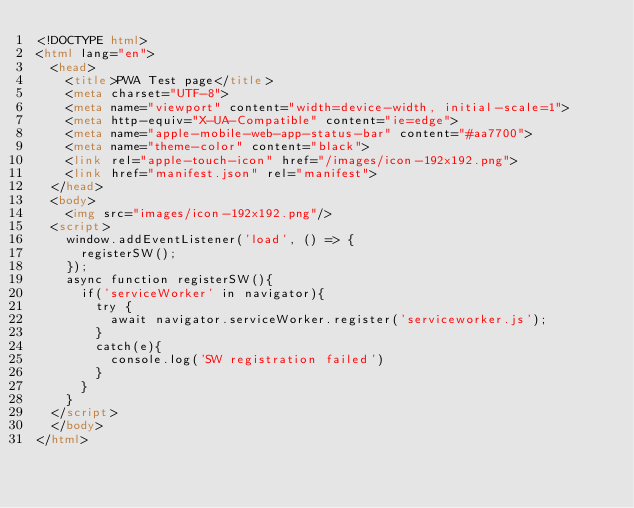<code> <loc_0><loc_0><loc_500><loc_500><_HTML_><!DOCTYPE html>
<html lang="en">
  <head>
    <title>PWA Test page</title>
    <meta charset="UTF-8">
    <meta name="viewport" content="width=device-width, initial-scale=1">
    <meta http-equiv="X-UA-Compatible" content="ie=edge">
    <meta name="apple-mobile-web-app-status-bar" content="#aa7700">
    <meta name="theme-color" content="black">
    <link rel="apple-touch-icon" href="/images/icon-192x192.png">
    <link href="manifest.json" rel="manifest">
  </head>
  <body>
    <img src="images/icon-192x192.png"/>
  <script>
    window.addEventListener('load', () => {
      registerSW();
    }); 
    async function registerSW(){
      if('serviceWorker' in navigator){
        try {
          await navigator.serviceWorker.register('serviceworker.js');
        }
        catch(e){
          console.log('SW registration failed')
        }
      }
    }
  </script>
  </body>
</html>
</code> 